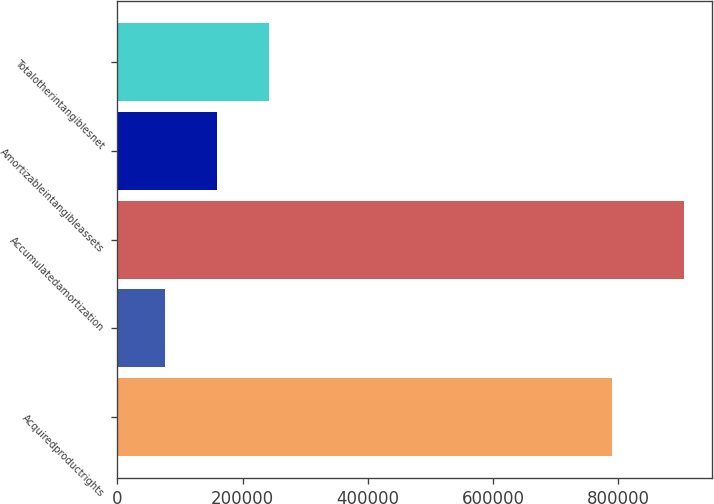Convert chart to OTSL. <chart><loc_0><loc_0><loc_500><loc_500><bar_chart><fcel>Acquiredproductrights<fcel>Unnamed: 1<fcel>Accumulatedamortization<fcel>Amortizableintangibleassets<fcel>Totalotherintangiblesnet<nl><fcel>789940<fcel>75738<fcel>904851<fcel>158649<fcel>241561<nl></chart> 